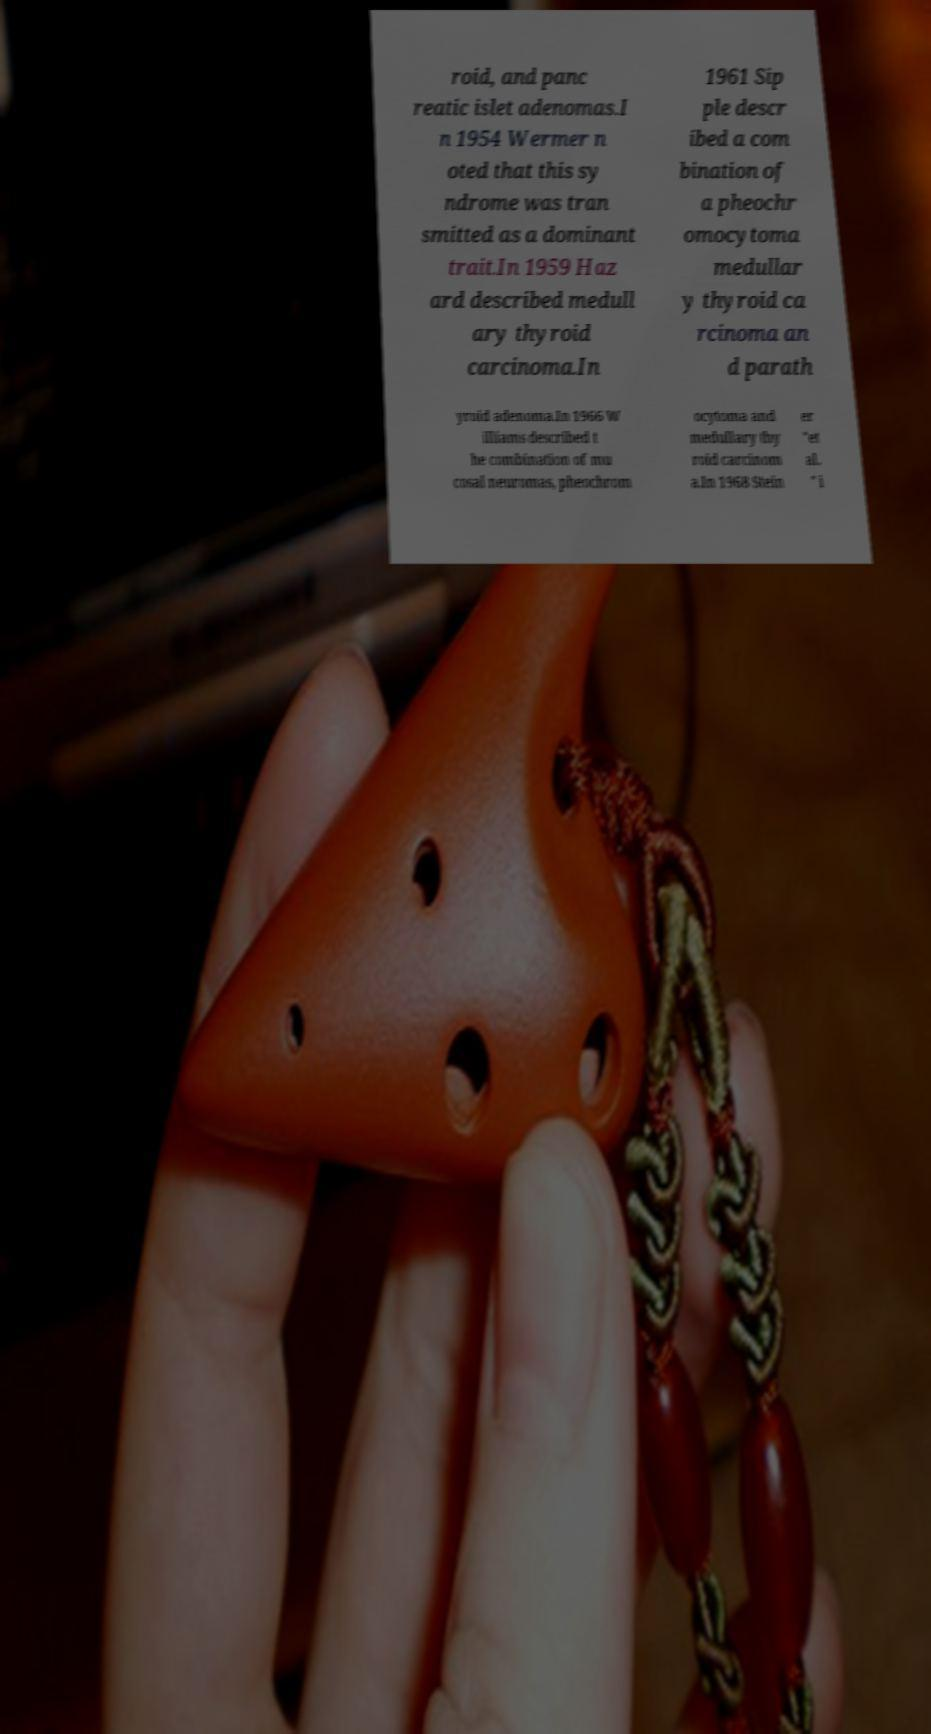Please identify and transcribe the text found in this image. roid, and panc reatic islet adenomas.I n 1954 Wermer n oted that this sy ndrome was tran smitted as a dominant trait.In 1959 Haz ard described medull ary thyroid carcinoma.In 1961 Sip ple descr ibed a com bination of a pheochr omocytoma medullar y thyroid ca rcinoma an d parath yroid adenoma.In 1966 W illiams described t he combination of mu cosal neuromas, pheochrom ocytoma and medullary thy roid carcinom a.In 1968 Stein er "et al. " i 